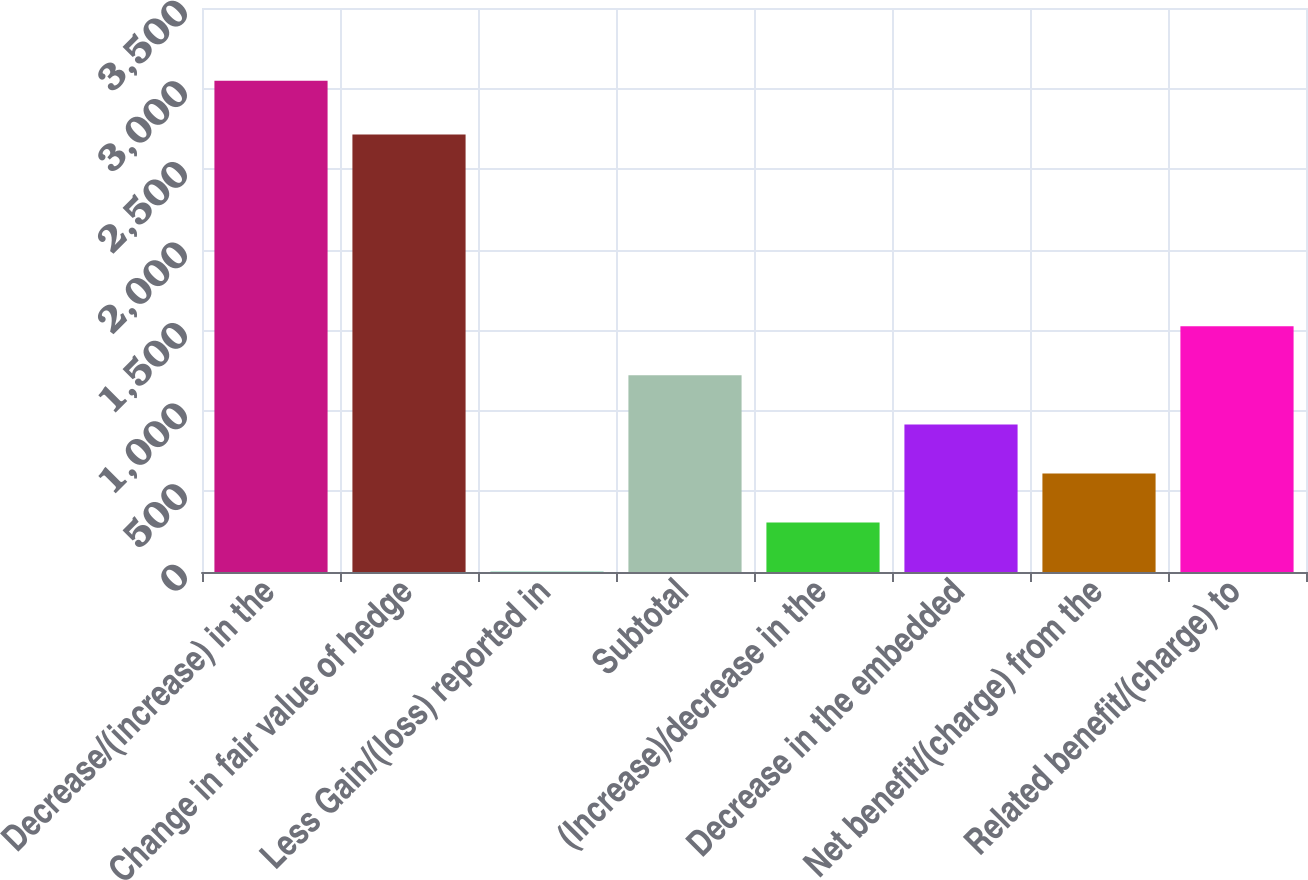<chart> <loc_0><loc_0><loc_500><loc_500><bar_chart><fcel>Decrease/(increase) in the<fcel>Change in fair value of hedge<fcel>Less Gain/(loss) reported in<fcel>Subtotal<fcel>(Increase)/decrease in the<fcel>Decrease in the embedded<fcel>Net benefit/(charge) from the<fcel>Related benefit/(charge) to<nl><fcel>3049<fcel>2715<fcel>1.74<fcel>1220.66<fcel>306.47<fcel>915.93<fcel>611.2<fcel>1525.39<nl></chart> 